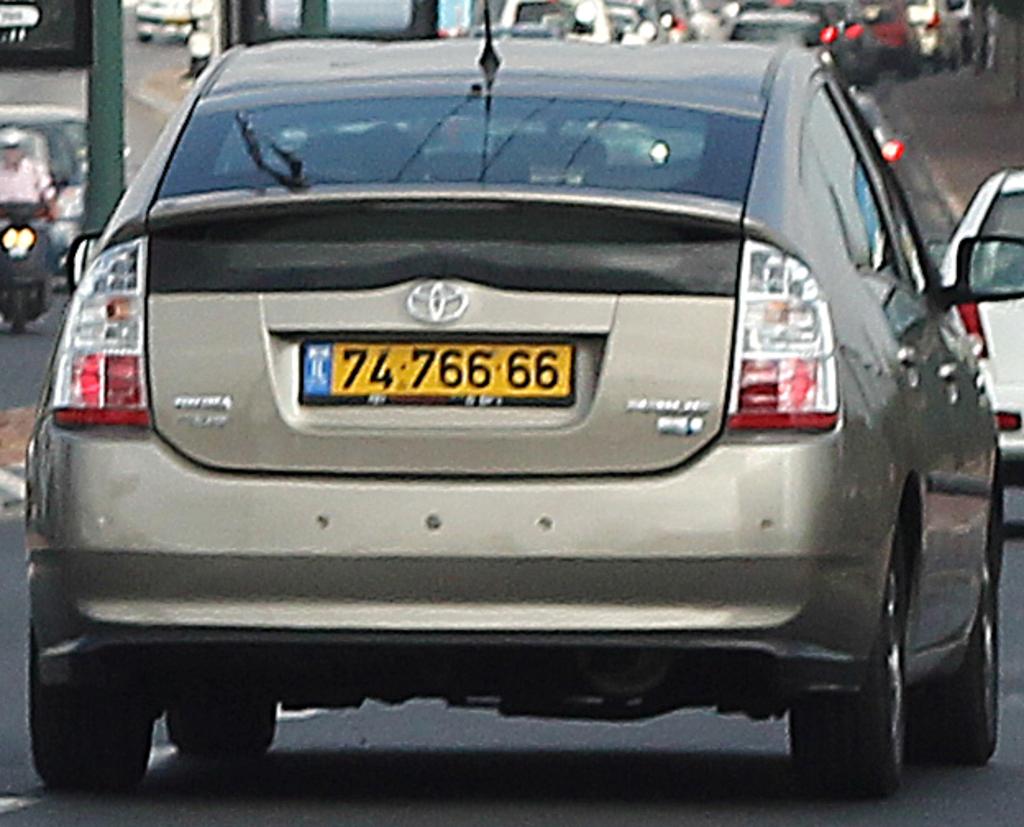What is the license plate number?
Give a very brief answer. 7476666. 